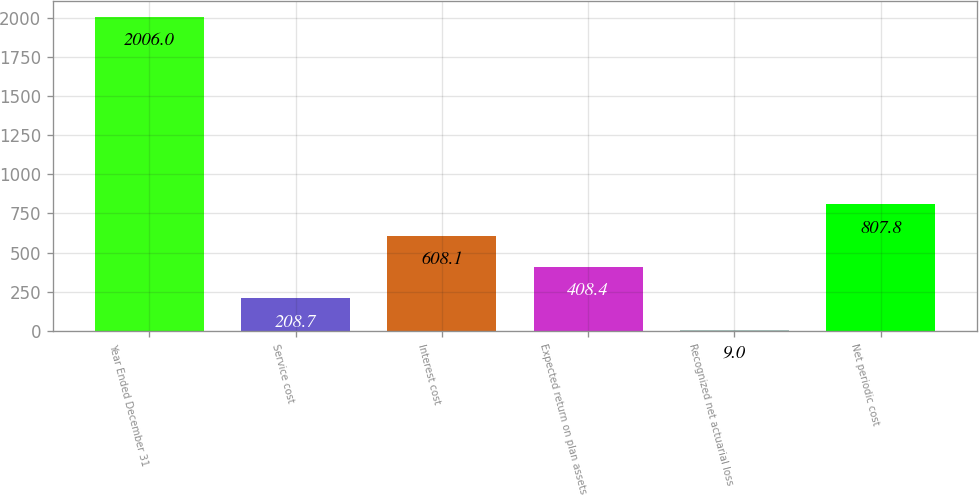Convert chart to OTSL. <chart><loc_0><loc_0><loc_500><loc_500><bar_chart><fcel>Year Ended December 31<fcel>Service cost<fcel>Interest cost<fcel>Expected return on plan assets<fcel>Recognized net actuarial loss<fcel>Net periodic cost<nl><fcel>2006<fcel>208.7<fcel>608.1<fcel>408.4<fcel>9<fcel>807.8<nl></chart> 